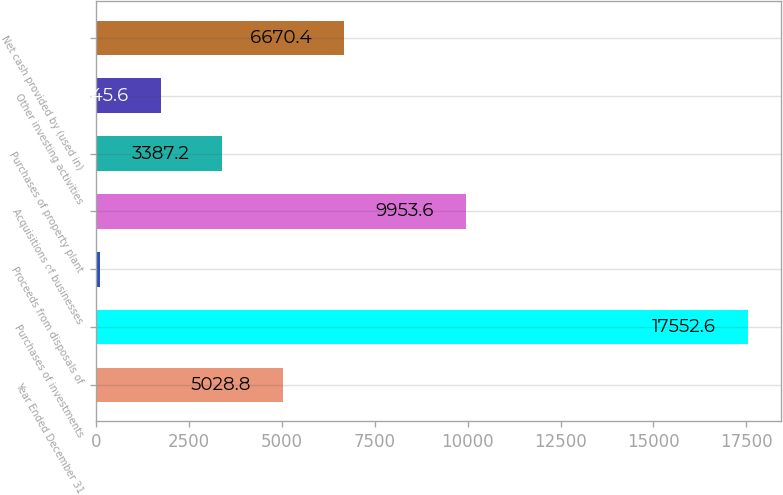Convert chart to OTSL. <chart><loc_0><loc_0><loc_500><loc_500><bar_chart><fcel>Year Ended December 31<fcel>Purchases of investments<fcel>Proceeds from disposals of<fcel>Acquisitions of businesses<fcel>Purchases of property plant<fcel>Other investing activities<fcel>Net cash provided by (used in)<nl><fcel>5028.8<fcel>17552.6<fcel>104<fcel>9953.6<fcel>3387.2<fcel>1745.6<fcel>6670.4<nl></chart> 